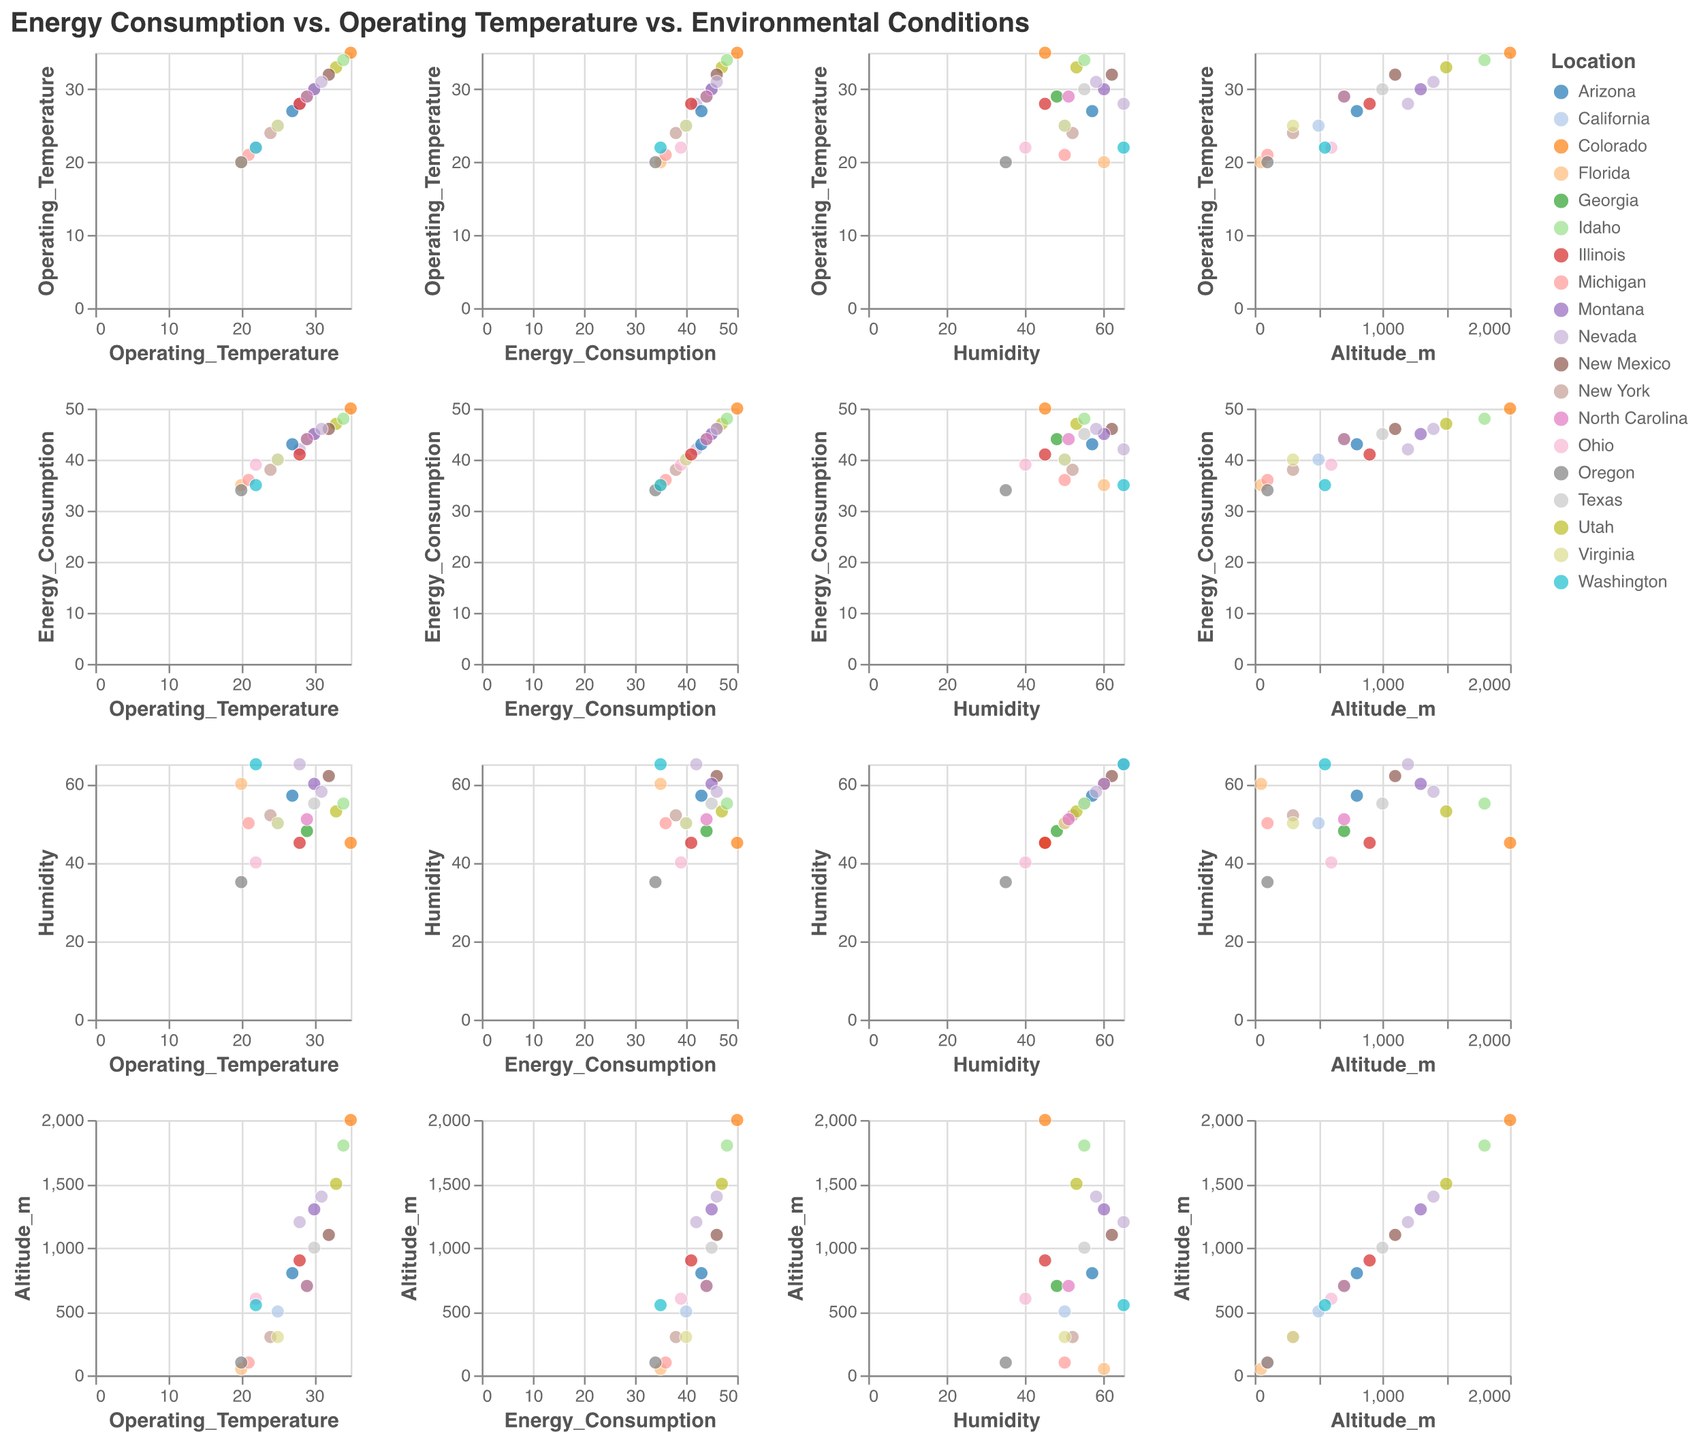What's the title of the plot? The title is placed at the top of the figure and is often the first element to catch the viewer's attention. In this plot, it reads "Energy Consumption vs. Operating Temperature vs. Environmental Conditions" which indicates what the scatter plot matrix is depicting.
Answer: Energy Consumption vs. Operating Temperature vs. Environmental Conditions How many different locations are represented in the plot? By examining the legend typically positioned to the side of the scatter plot matrix, which lists all distinct locations by color, one can count the number of unique locations.
Answer: 20 Which location has the highest energy consumption? Identify the highest point in the Energy Consumption column on the y-axis. Find the corresponding point and refer to the location tagged in the tooltip or the colored legend. The highest value for energy consumption is "50", which corresponds to Colorado.
Answer: Colorado What's the relationship between Operating Temperature and Energy Consumption? By looking at the scatter plots where Operating Temperature is on one axis and Energy Consumption is on the other, one would generally observe if there's a positive, negative, or no correlation between the two variables. A general upward trend in the points would indicate a positive correlation.
Answer: Positive correlation Which combination of Operating Temperature and Humidity is observed in Florida? Locate the symbol for Florida in the legend and then find this symbol in the scatter plot matrix where one axis is Operating Temperature and the other is Humidity. The data point corresponding to Florida will give you the values. Florida has an Operating Temperature of 20 and Humidity of 60.
Answer: Operating Temperature: 20, Humidity: 60 How does altitude influence energy consumption? To assess this, examine the scatter plots that have Altitude on one axis and Energy Consumption on the other. Track the trend of data points to determine if higher altitudes tend to have higher or lower energy consumption, or if there's no clear pattern.
Answer: Higher altitude tends to have higher energy consumption In which location do we find the lowest operating temperature, and what is the corresponding energy consumption? Locate the data point with the lowest operating temperature value and then read off the corresponding energy consumption. This data point will also show the location, which can be matched with the legend colors. The lowest operating temperature is 20, observed in Florida and Oregon, with energy consumption values of 35 and 34, respectively.
Answer: Florida and Oregon, Energy Consumption: 35, 34 What is the range of humidity values across all locations? Find the minimum and maximum values of the Humidity axis by locating the lowest and highest points in the scatter plot matrix.
Answer: 35 to 65 Which two locations closest in terms of their energy consumption and operating temperature values? By observing the scatter plots where Energy Consumption is on one axis and Operating Temperature on another, identify the pairs of points that are closest to each other both horizontally and vertically. Visual proximity indicates similarity in values. It appears California and Virginia are very close with operating temperatures of 25 and energy consumption of 40.
Answer: California and Virginia How does humidity vary with energy consumption in Texas compared to Idaho? Find the data points for Texas and Idaho (using their legend colors) in the scatter plot matrix where Humidity is on one axis and Energy Consumption on the other. Note the relative vertical positions of these points to understand how humidity varies with energy consumption in these two locations. Texas has slightly lower humidity (55) at a higher energy consumption (45) compared to Idaho, where at energy consumption (48), the humidity is 55.
Answer: Texas: Humidity 55, Energy Consumption 45; Idaho: Humidity 55, Energy Consumption 48 